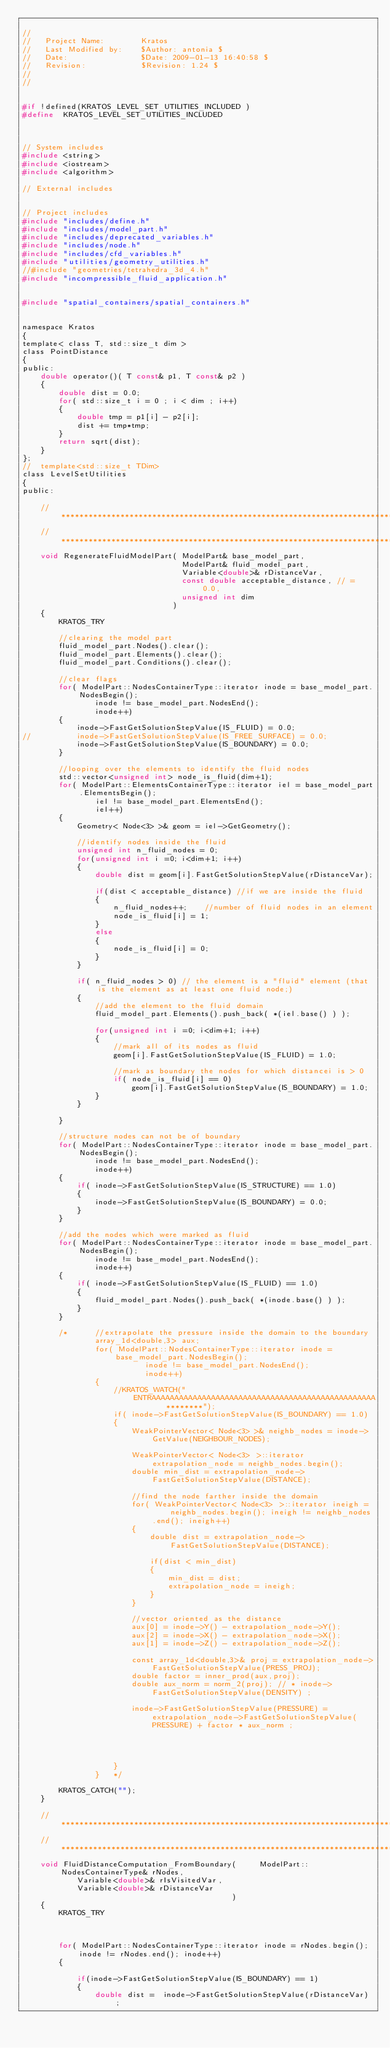<code> <loc_0><loc_0><loc_500><loc_500><_C_>
//
//   Project Name:        Kratos
//   Last Modified by:    $Author: antonia $
//   Date:                $Date: 2009-01-13 16:40:58 $
//   Revision:            $Revision: 1.24 $
//
//


#if !defined(KRATOS_LEVEL_SET_UTILITIES_INCLUDED )
#define  KRATOS_LEVEL_SET_UTILITIES_INCLUDED



// System includes
#include <string>
#include <iostream>
#include <algorithm>

// External includes


// Project includes
#include "includes/define.h"
#include "includes/model_part.h"
#include "includes/deprecated_variables.h"
#include "includes/node.h"
#include "includes/cfd_variables.h"
#include "utilities/geometry_utilities.h"
//#include "geometries/tetrahedra_3d_4.h"
#include "incompressible_fluid_application.h"


#include "spatial_containers/spatial_containers.h"


namespace Kratos
{
template< class T, std::size_t dim >
class PointDistance
{
public:
    double operator()( T const& p1, T const& p2 )
    {
        double dist = 0.0;
        for( std::size_t i = 0 ; i < dim ; i++)
        {
            double tmp = p1[i] - p2[i];
            dist += tmp*tmp;
        }
        return sqrt(dist);
    }
};
// 	template<std::size_t TDim>
class LevelSetUtilities
{
public:

    //***************************************************************************************
    //***************************************************************************************
    void RegenerateFluidModelPart( ModelPart& base_model_part,
                                   ModelPart& fluid_model_part,
                                   Variable<double>& rDistanceVar,
                                   const double acceptable_distance, // = 0.0,
                                   unsigned int dim
                                 )
    {
        KRATOS_TRY

        //clearing the model part
        fluid_model_part.Nodes().clear();
        fluid_model_part.Elements().clear();
        fluid_model_part.Conditions().clear();

        //clear flags
        for( ModelPart::NodesContainerType::iterator inode = base_model_part.NodesBegin();
                inode != base_model_part.NodesEnd();
                inode++)
        {
            inode->FastGetSolutionStepValue(IS_FLUID) = 0.0;
//			inode->FastGetSolutionStepValue(IS_FREE_SURFACE) = 0.0;
            inode->FastGetSolutionStepValue(IS_BOUNDARY) = 0.0;
        }

        //looping over the elements to identify the fluid nodes
        std::vector<unsigned int> node_is_fluid(dim+1);
        for( ModelPart::ElementsContainerType::iterator iel = base_model_part.ElementsBegin();
                iel != base_model_part.ElementsEnd();
                iel++)
        {
            Geometry< Node<3> >& geom = iel->GetGeometry();

            //identify nodes inside the fluid
            unsigned int n_fluid_nodes = 0;
            for(unsigned int i =0; i<dim+1; i++)
            {
                double dist = geom[i].FastGetSolutionStepValue(rDistanceVar);

                if(dist < acceptable_distance) //if we are inside the fluid
                {
                    n_fluid_nodes++;	//number of fluid nodes in an element
                    node_is_fluid[i] = 1;
                }
                else
                {
                    node_is_fluid[i] = 0;
                }
            }

            if( n_fluid_nodes > 0) // the element is a "fluid" element (that is the element as at least one fluid node;)
            {
                //add the element to the fluid domain
                fluid_model_part.Elements().push_back( *(iel.base() ) );

                for(unsigned int i =0; i<dim+1; i++)
                {
                    //mark all of its nodes as fluid
                    geom[i].FastGetSolutionStepValue(IS_FLUID) = 1.0;

                    //mark as boundary the nodes for which distancei is > 0
                    if( node_is_fluid[i] == 0)
                        geom[i].FastGetSolutionStepValue(IS_BOUNDARY) = 1.0;
                }
            }

        }

        //structure nodes can not be of boundary
        for( ModelPart::NodesContainerType::iterator inode = base_model_part.NodesBegin();
                inode != base_model_part.NodesEnd();
                inode++)
        {
            if( inode->FastGetSolutionStepValue(IS_STRUCTURE) == 1.0)
            {
                inode->FastGetSolutionStepValue(IS_BOUNDARY) = 0.0;
            }
        }

        //add the nodes which were marked as fluid
        for( ModelPart::NodesContainerType::iterator inode = base_model_part.NodesBegin();
                inode != base_model_part.NodesEnd();
                inode++)
        {
            if( inode->FastGetSolutionStepValue(IS_FLUID) == 1.0)
            {
                fluid_model_part.Nodes().push_back( *(inode.base() ) );
            }
        }

        /*		//extrapolate the pressure inside the domain to the boundary
        		array_1d<double,3> aux;
        		for( ModelPart::NodesContainerType::iterator inode = base_model_part.NodesBegin();
        				   inode != base_model_part.NodesEnd();
        				   inode++)
        		{
        			//KRATOS_WATCH("	ENTRAAAAAAAAAAAAAAAAAAAAAAAAAAAAAAAAAAAAAAAAAAAAAAAAA		********");
        			if( inode->FastGetSolutionStepValue(IS_BOUNDARY) == 1.0)
        			{
        				WeakPointerVector< Node<3> >& neighb_nodes = inode->GetValue(NEIGHBOUR_NODES);

        				WeakPointerVector< Node<3> >::iterator extrapolation_node = neighb_nodes.begin();
        				double min_dist = extrapolation_node->FastGetSolutionStepValue(DISTANCE);

        				//find the node farther inside the domain
        				for( WeakPointerVector< Node<3> >::iterator ineigh =	neighb_nodes.begin(); ineigh != neighb_nodes.end(); ineigh++)
        				{
        					double dist = extrapolation_node->FastGetSolutionStepValue(DISTANCE);

        					if(dist < min_dist)
        					{
        						min_dist = dist;
        						extrapolation_node = ineigh;
        					}
        				}

        				//vector oriented as the distance
        				aux[0] = inode->Y() - extrapolation_node->Y();
        				aux[2] = inode->X() - extrapolation_node->X();
        				aux[1] = inode->Z() - extrapolation_node->Z();

        				const array_1d<double,3>& proj = extrapolation_node->FastGetSolutionStepValue(PRESS_PROJ);
        				double factor = inner_prod(aux,proj);
        				double aux_norm = norm_2(proj); // * inode->FastGetSolutionStepValue(DENSITY) ;

        				inode->FastGetSolutionStepValue(PRESSURE) = extrapolation_node->FastGetSolutionStepValue(PRESSURE) + factor * aux_norm ;




        			}
        		}	*/

        KRATOS_CATCH("");
    }

    //***************************************************************************************
    //***************************************************************************************
    void FluidDistanceComputation_FromBoundary( 	ModelPart::NodesContainerType& rNodes,
            Variable<double>& rIsVisitedVar,
            Variable<double>& rDistanceVar
                                              )
    {
        KRATOS_TRY



        for( ModelPart::NodesContainerType::iterator inode = rNodes.begin(); inode != rNodes.end(); inode++)
        {

            if(inode->FastGetSolutionStepValue(IS_BOUNDARY) == 1)
            {
                double dist =  inode->FastGetSolutionStepValue(rDistanceVar) ;</code> 